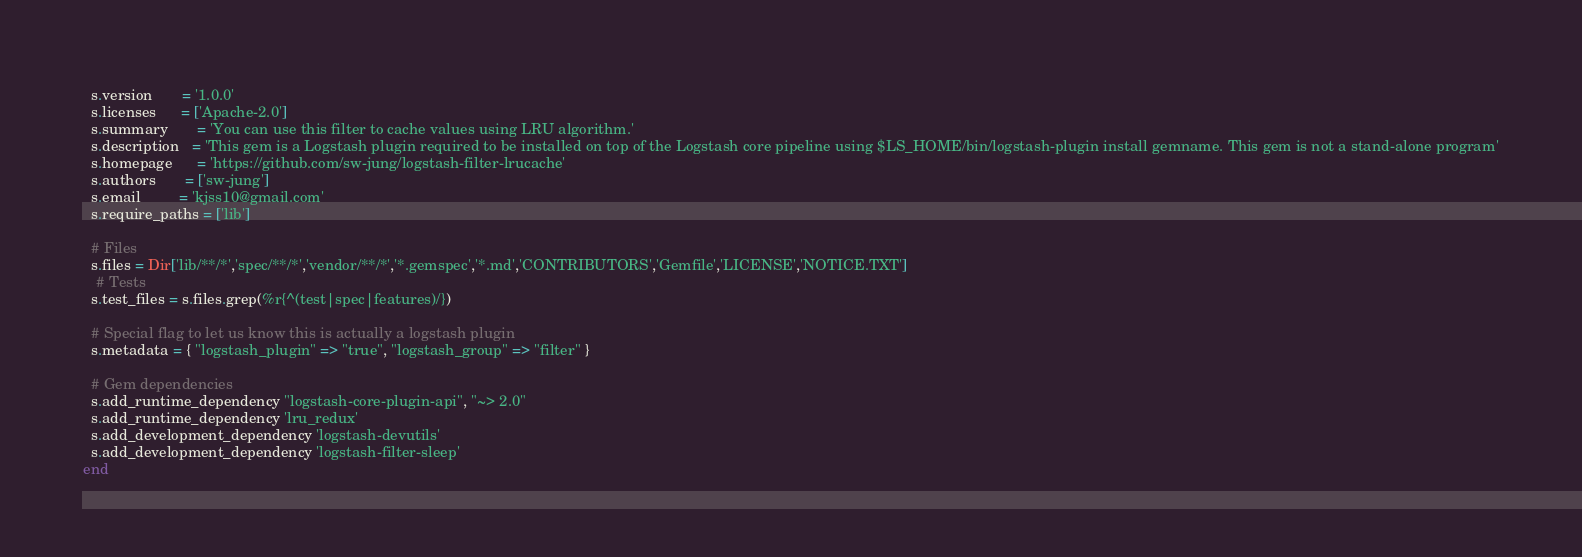Convert code to text. <code><loc_0><loc_0><loc_500><loc_500><_Ruby_>  s.version       = '1.0.0'
  s.licenses      = ['Apache-2.0']
  s.summary       = 'You can use this filter to cache values using LRU algorithm.'
  s.description   = 'This gem is a Logstash plugin required to be installed on top of the Logstash core pipeline using $LS_HOME/bin/logstash-plugin install gemname. This gem is not a stand-alone program'
  s.homepage      = 'https://github.com/sw-jung/logstash-filter-lrucache'
  s.authors       = ['sw-jung']
  s.email         = 'kjss10@gmail.com'
  s.require_paths = ['lib']

  # Files
  s.files = Dir['lib/**/*','spec/**/*','vendor/**/*','*.gemspec','*.md','CONTRIBUTORS','Gemfile','LICENSE','NOTICE.TXT']
   # Tests
  s.test_files = s.files.grep(%r{^(test|spec|features)/})

  # Special flag to let us know this is actually a logstash plugin
  s.metadata = { "logstash_plugin" => "true", "logstash_group" => "filter" }

  # Gem dependencies
  s.add_runtime_dependency "logstash-core-plugin-api", "~> 2.0"
  s.add_runtime_dependency 'lru_redux'
  s.add_development_dependency 'logstash-devutils'
  s.add_development_dependency 'logstash-filter-sleep'
end
</code> 